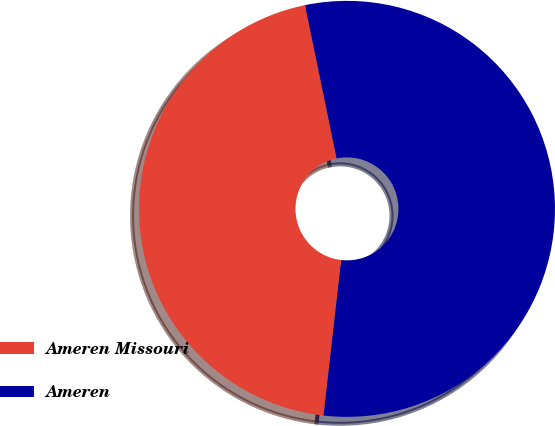<chart> <loc_0><loc_0><loc_500><loc_500><pie_chart><fcel>Ameren Missouri<fcel>Ameren<nl><fcel>44.97%<fcel>55.03%<nl></chart> 